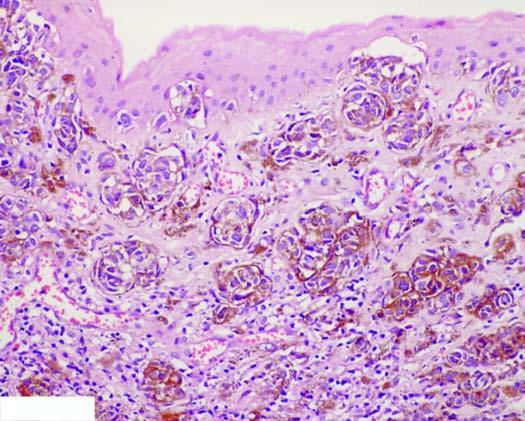do these cells contain coarse, granular, brown-black melanin pigment?
Answer the question using a single word or phrase. Yes 